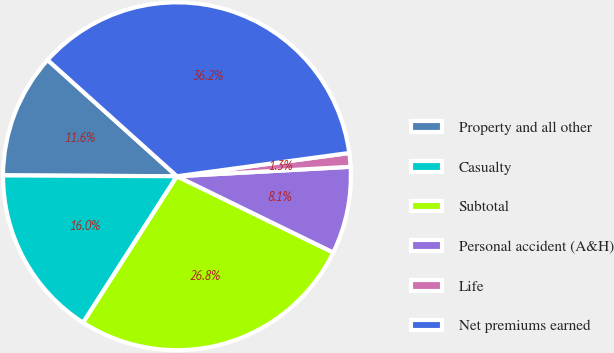<chart> <loc_0><loc_0><loc_500><loc_500><pie_chart><fcel>Property and all other<fcel>Casualty<fcel>Subtotal<fcel>Personal accident (A&H)<fcel>Life<fcel>Net premiums earned<nl><fcel>11.58%<fcel>16.01%<fcel>26.85%<fcel>8.09%<fcel>1.27%<fcel>36.21%<nl></chart> 